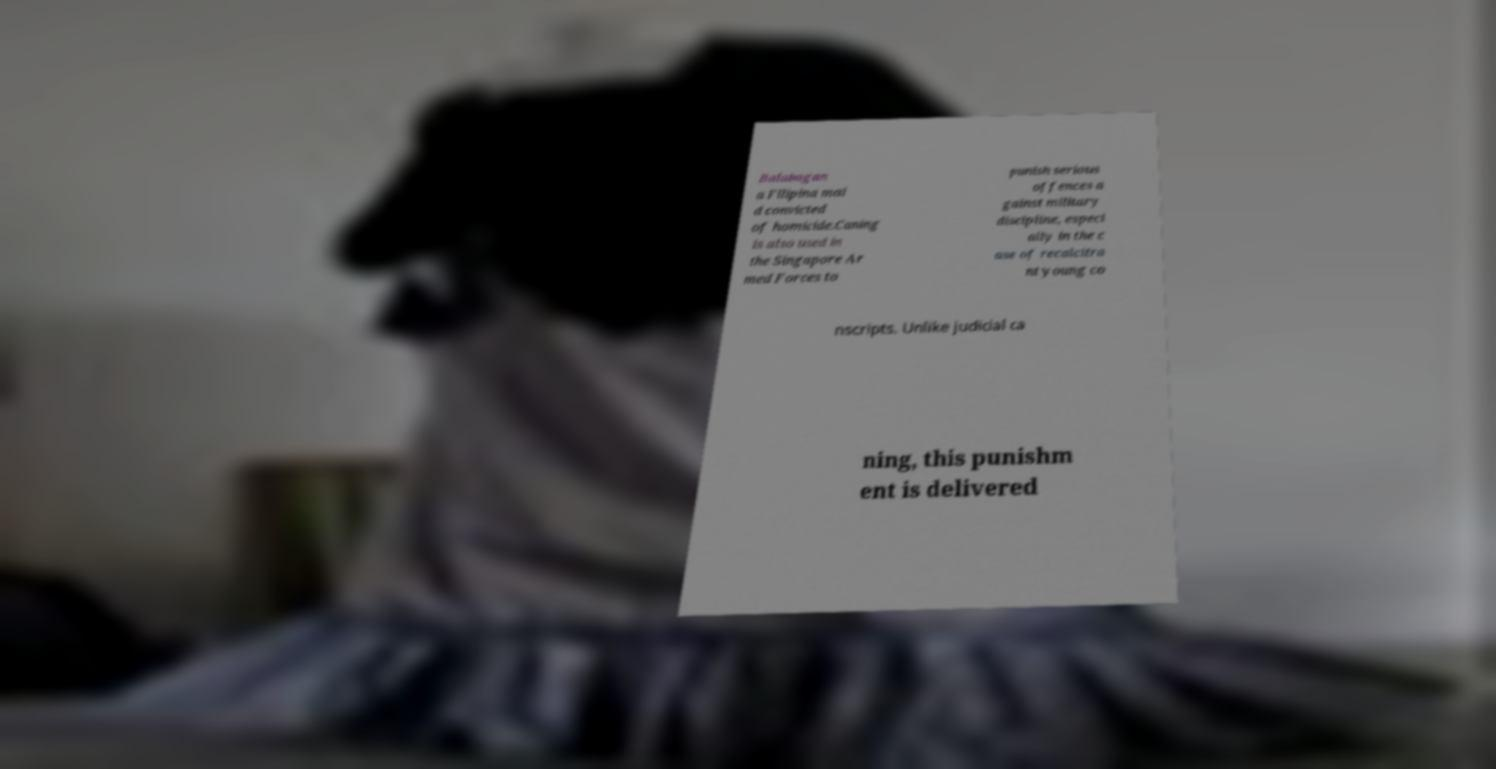Could you extract and type out the text from this image? Balabagan a Filipina mai d convicted of homicide.Caning is also used in the Singapore Ar med Forces to punish serious offences a gainst military discipline, especi ally in the c ase of recalcitra nt young co nscripts. Unlike judicial ca ning, this punishm ent is delivered 